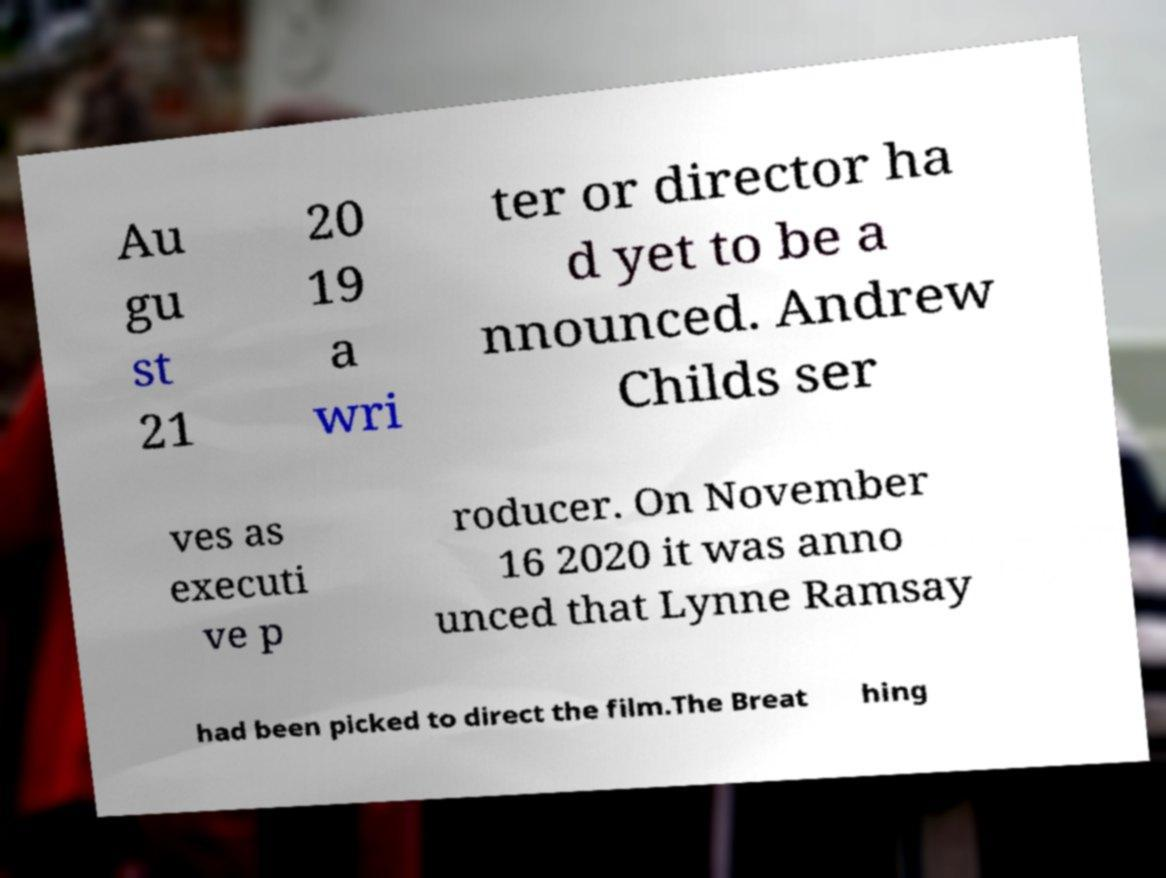Can you accurately transcribe the text from the provided image for me? Au gu st 21 20 19 a wri ter or director ha d yet to be a nnounced. Andrew Childs ser ves as executi ve p roducer. On November 16 2020 it was anno unced that Lynne Ramsay had been picked to direct the film.The Breat hing 